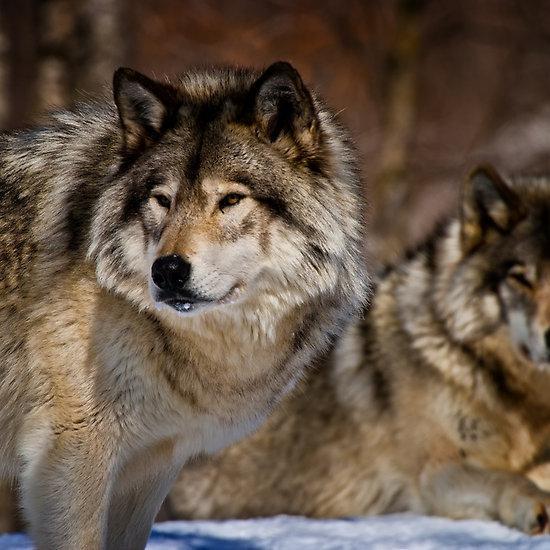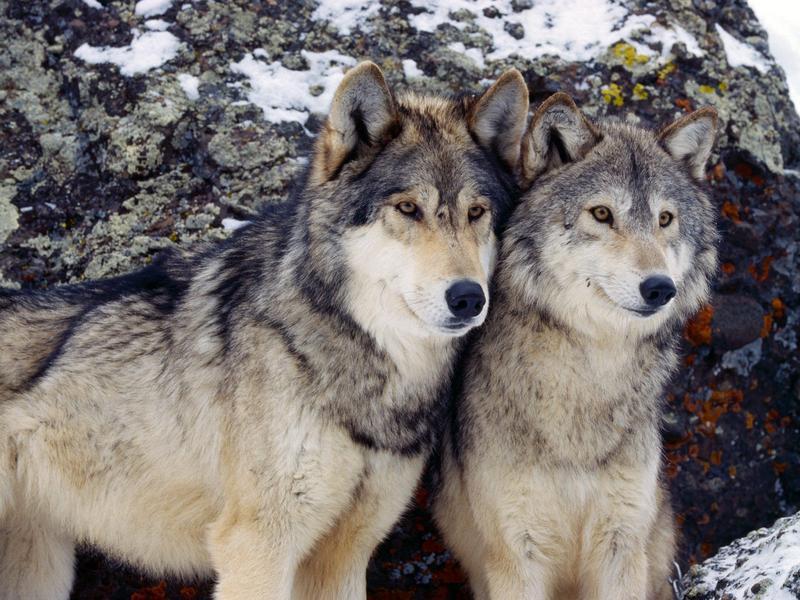The first image is the image on the left, the second image is the image on the right. Analyze the images presented: Is the assertion "There are at least five wolves." valid? Answer yes or no. No. The first image is the image on the left, the second image is the image on the right. Analyze the images presented: Is the assertion "In total, no more than four wolves are visible." valid? Answer yes or no. Yes. 